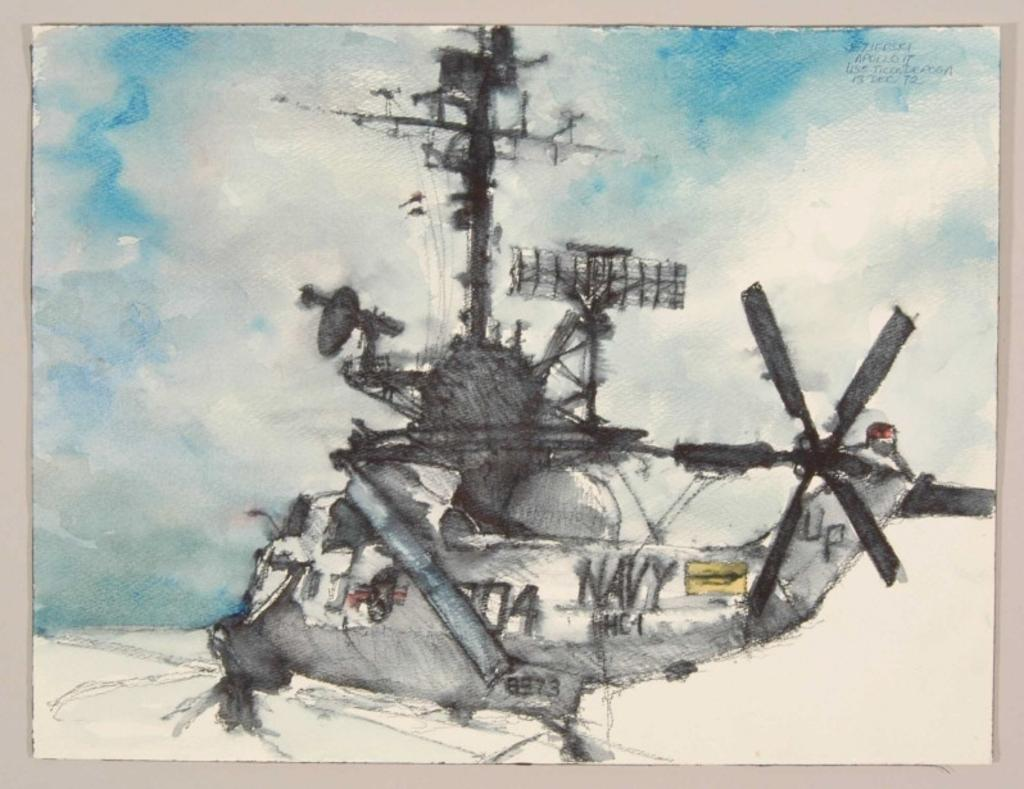<image>
Create a compact narrative representing the image presented. A painting of a helicopter with the word "NAVY" printed on the side. 